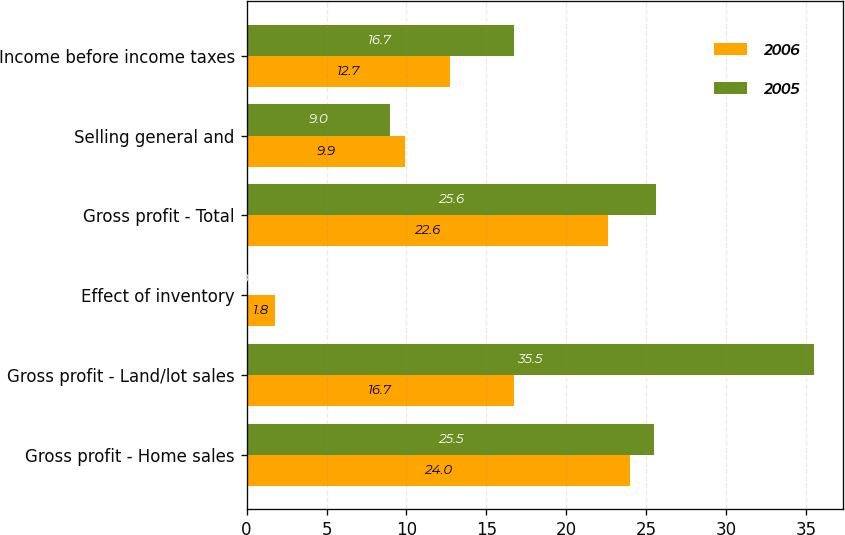<chart> <loc_0><loc_0><loc_500><loc_500><stacked_bar_chart><ecel><fcel>Gross profit - Home sales<fcel>Gross profit - Land/lot sales<fcel>Effect of inventory<fcel>Gross profit - Total<fcel>Selling general and<fcel>Income before income taxes<nl><fcel>2006<fcel>24<fcel>16.7<fcel>1.8<fcel>22.6<fcel>9.9<fcel>12.7<nl><fcel>2005<fcel>25.5<fcel>35.5<fcel>0.1<fcel>25.6<fcel>9<fcel>16.7<nl></chart> 